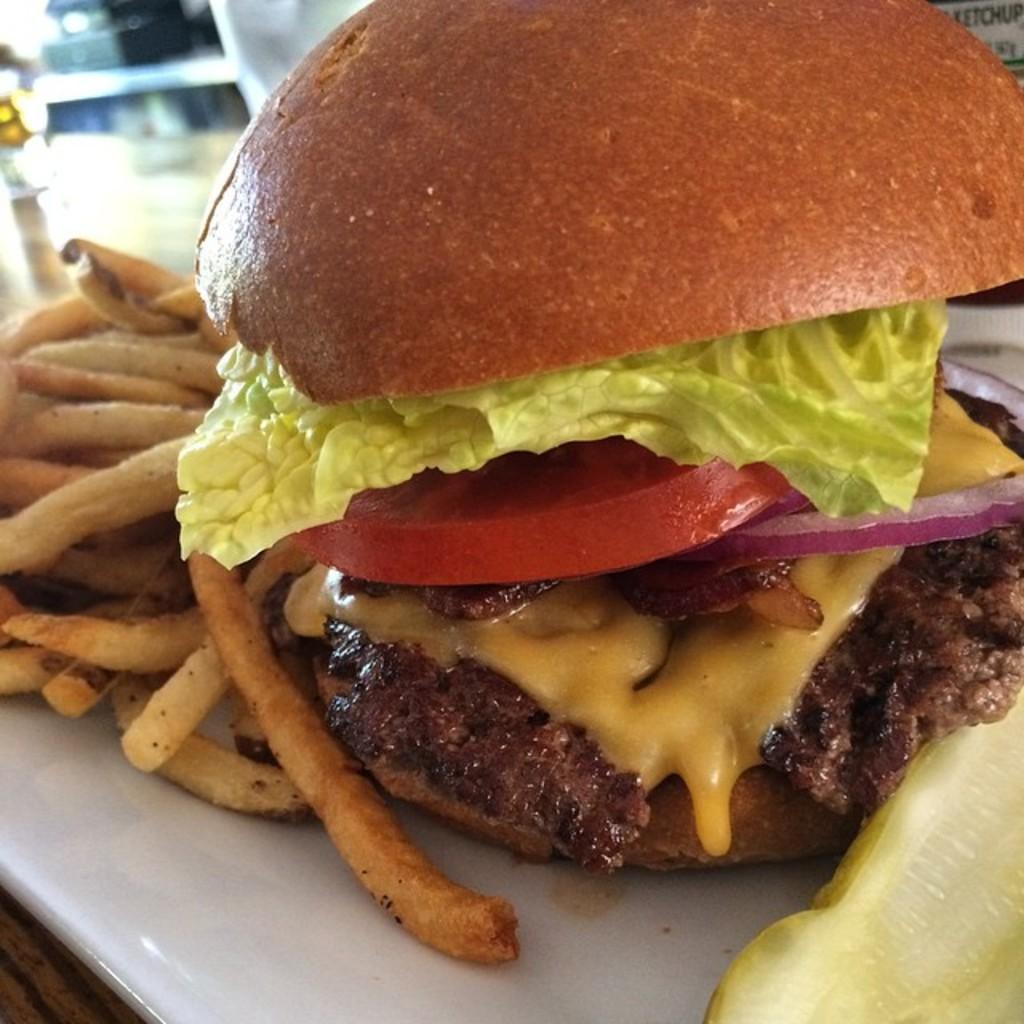In one or two sentences, can you explain what this image depicts? In this picture we can see a plate with food and fries on the wooden platform. In the background of the image it is blurry. 